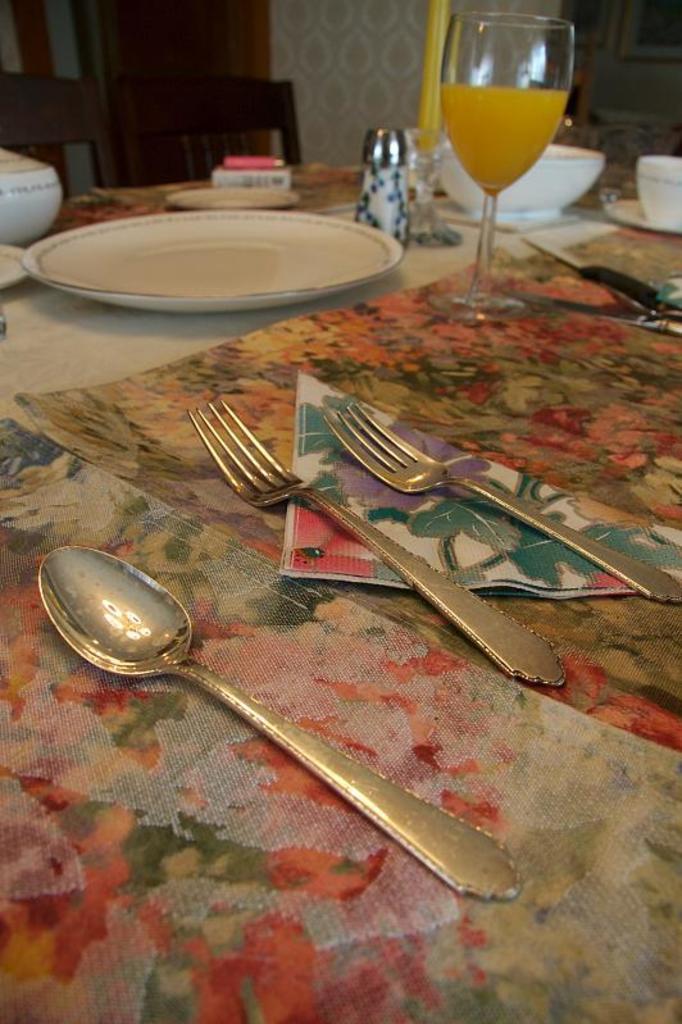In one or two sentences, can you explain what this image depicts? In the image in the center, we can see the table. On the table, we can see bowls, plates, forks, cup, saucer, glass, jar, spoon, knife and a few other objects. In the background there is a wall, door, chair etc. 